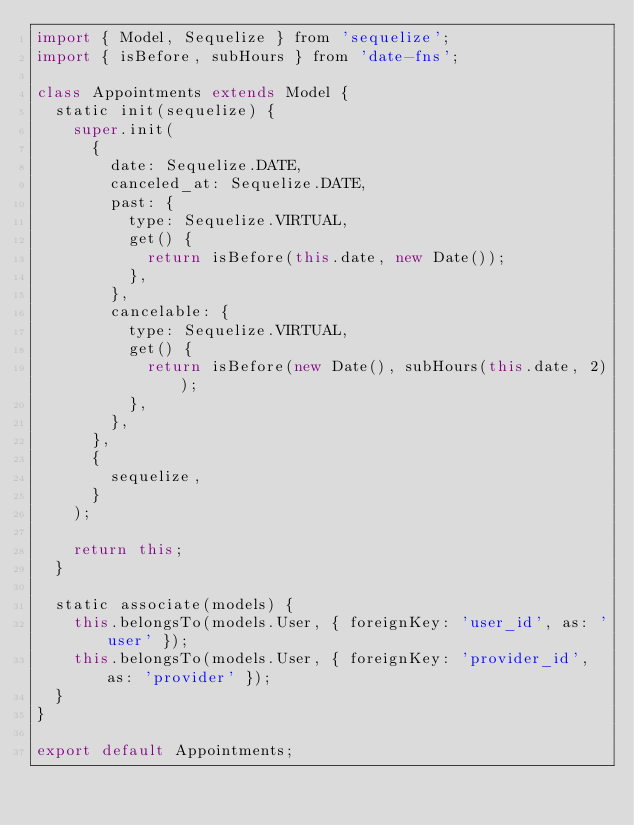<code> <loc_0><loc_0><loc_500><loc_500><_JavaScript_>import { Model, Sequelize } from 'sequelize';
import { isBefore, subHours } from 'date-fns';

class Appointments extends Model {
  static init(sequelize) {
    super.init(
      {
        date: Sequelize.DATE,
        canceled_at: Sequelize.DATE,
        past: {
          type: Sequelize.VIRTUAL,
          get() {
            return isBefore(this.date, new Date());
          },
        },
        cancelable: {
          type: Sequelize.VIRTUAL,
          get() {
            return isBefore(new Date(), subHours(this.date, 2));
          },
        },
      },
      {
        sequelize,
      }
    );

    return this;
  }

  static associate(models) {
    this.belongsTo(models.User, { foreignKey: 'user_id', as: 'user' });
    this.belongsTo(models.User, { foreignKey: 'provider_id', as: 'provider' });
  }
}

export default Appointments;
</code> 